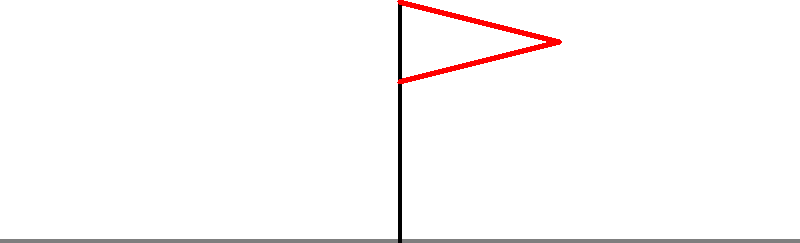In this photograph from the Apollo moon landing, why does the flag appear to be waving when there's supposedly no atmosphere on the moon? 1. The appearance of the flag "waving" in Apollo mission photographs is a common point of contention for moon landing skeptics.

2. In reality, the flag is not waving. The appearance is due to the flag's design and the way it was planted:

   a. The flag had a horizontal rod at the top to keep it extended.
   b. The rod didn't fully extend, causing wrinkles in the fabric.
   c. These wrinkles give the illusion of movement or "waving."

3. The flag's design was intentional to make it visible in still photographs, as a limp flag in the absence of wind would not be photogenic.

4. The moon's lack of atmosphere means there's no wind to cause the flag to wave. Once positioned, the flag remained in that static, wrinkled state.

5. The lighting conditions on the moon, with harsh shadows and no atmospheric scattering, can enhance the appearance of texture and wrinkles in the flag.

6. Multiple photographs of the same flag from different angles consistently show the same wrinkle pattern, confirming its static nature.

7. If the flag were actually waving, it would require an atmosphere or some other force, which would contradict other observable phenomena in the lunar environment.

Therefore, the appearance of the "waving" flag is a result of its design and photographic conditions, not evidence of atmospheric movement on the moon.
Answer: Flag design and lighting effects, not atmospheric movement. 